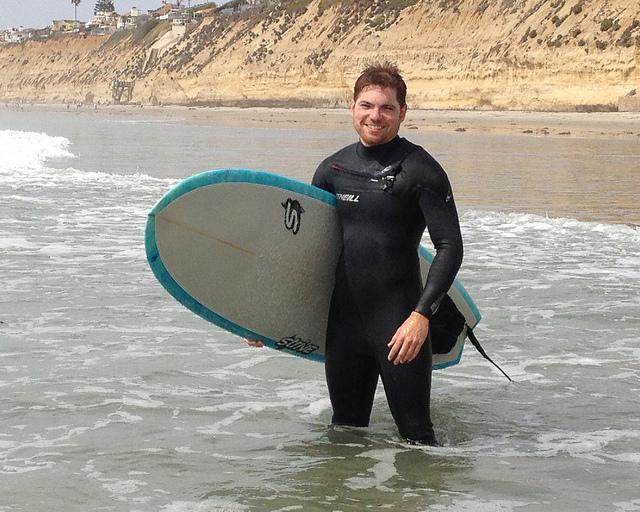Is the man facing towards or away from the camera?
Concise answer only. Towards. What color is the trimming on the surf board?
Short answer required. Blue. What is his outfit called?
Give a very brief answer. Wetsuit. What is the man holding?
Quick response, please. Surfboard. 